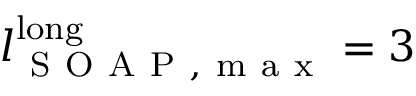<formula> <loc_0><loc_0><loc_500><loc_500>l _ { S O A P , m a x } ^ { l o n g } = 3</formula> 